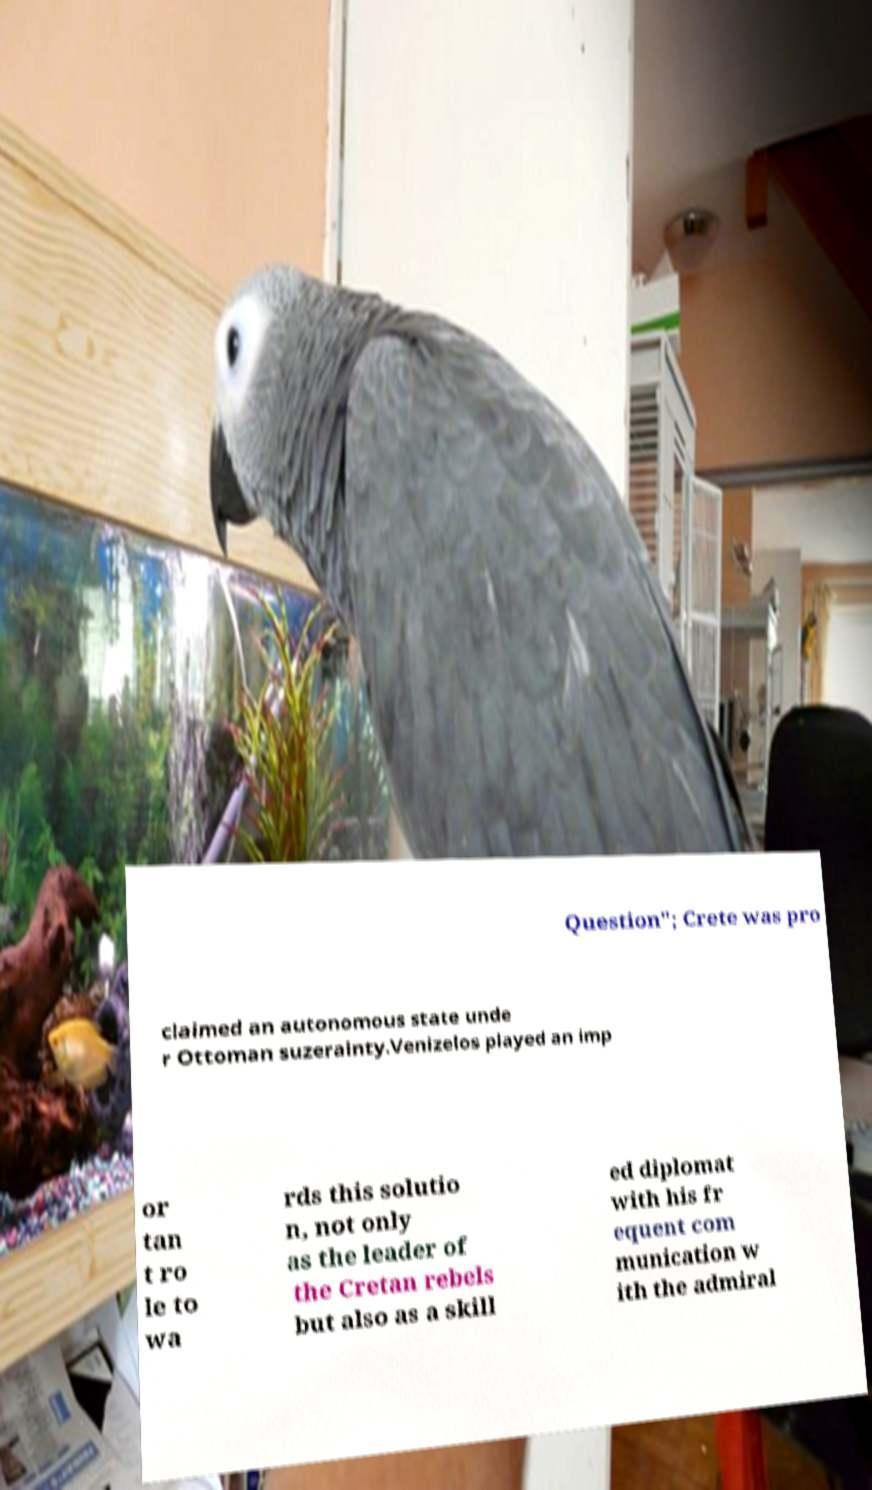Can you accurately transcribe the text from the provided image for me? Question"; Crete was pro claimed an autonomous state unde r Ottoman suzerainty.Venizelos played an imp or tan t ro le to wa rds this solutio n, not only as the leader of the Cretan rebels but also as a skill ed diplomat with his fr equent com munication w ith the admiral 